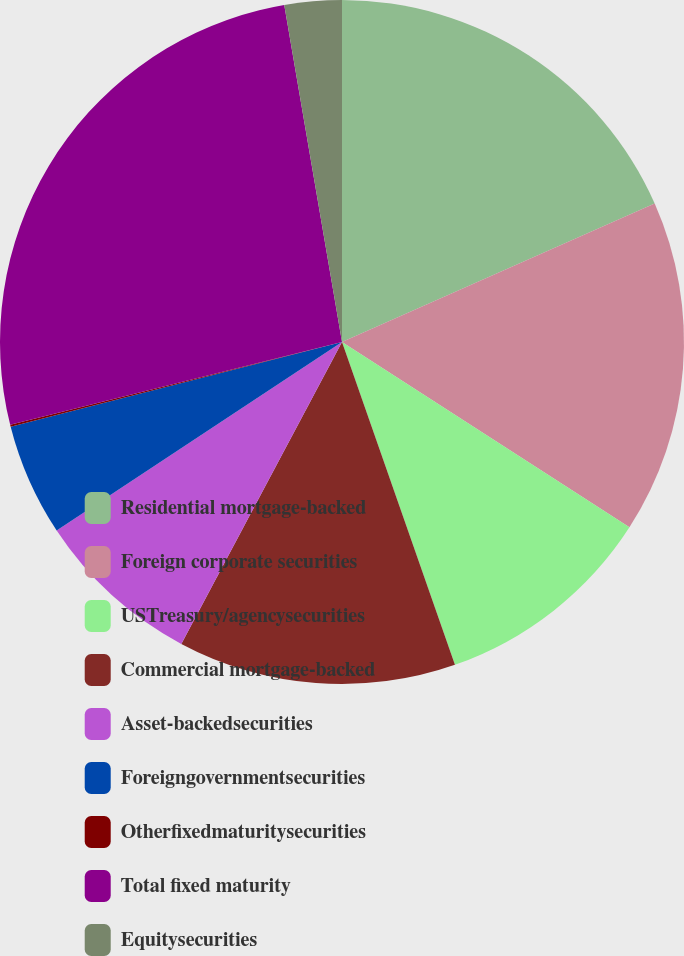Convert chart. <chart><loc_0><loc_0><loc_500><loc_500><pie_chart><fcel>Residential mortgage-backed<fcel>Foreign corporate securities<fcel>USTreasury/agencysecurities<fcel>Commercial mortgage-backed<fcel>Asset-backedsecurities<fcel>Foreigngovernmentsecurities<fcel>Otherfixedmaturitysecurities<fcel>Total fixed maturity<fcel>Equitysecurities<nl><fcel>18.36%<fcel>15.75%<fcel>10.53%<fcel>13.14%<fcel>7.92%<fcel>5.31%<fcel>0.09%<fcel>26.19%<fcel>2.7%<nl></chart> 